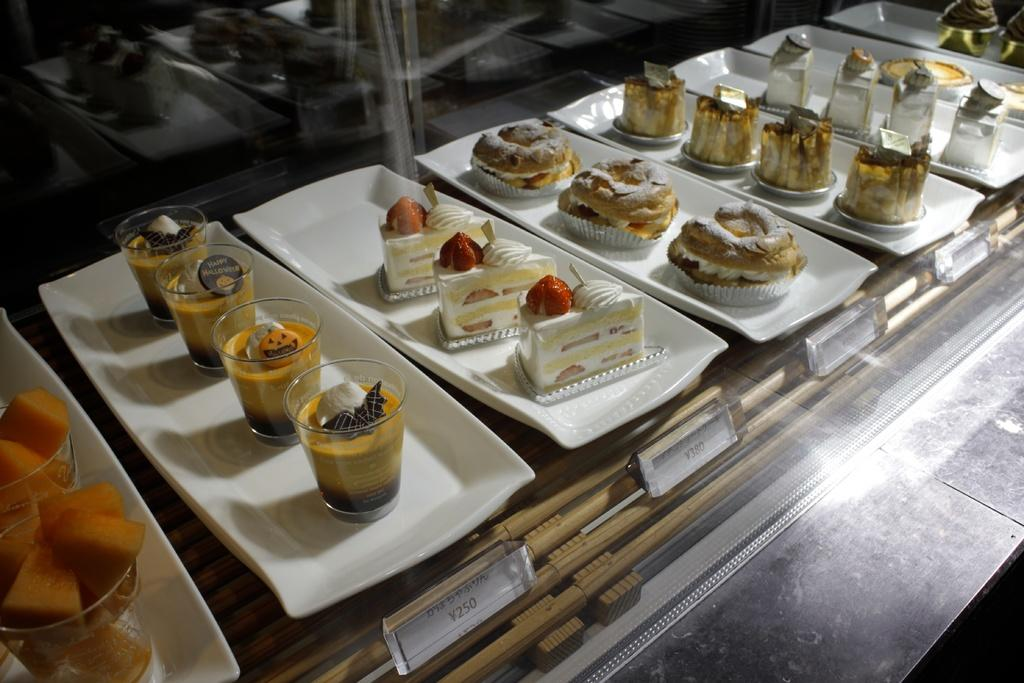What type of food can be seen in the image? There are cakes and glasses with food in the image. How are the cakes and glasses arranged in the image? The cakes and glasses are placed on trays in the image. What other items can be seen in the image besides the cakes and glasses? There are boards and additional objects in the image. What type of sign can be seen in the image? There is no sign present in the image. What story is being told through the cakes and glasses in the image? The image does not tell a story; it simply shows cakes and glasses with food on trays. 